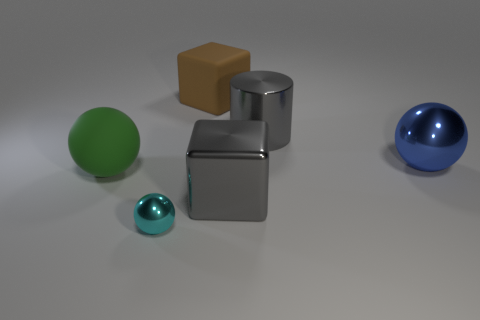Are there any other things that have the same size as the cyan shiny sphere?
Your response must be concise. No. What is the tiny cyan object made of?
Offer a terse response. Metal. What is the sphere that is on the left side of the metal object in front of the big gray shiny object that is to the left of the cylinder made of?
Offer a terse response. Rubber. There is a brown thing that is the same size as the matte sphere; what shape is it?
Your answer should be very brief. Cube. What number of objects are big brown rubber spheres or large objects behind the large blue sphere?
Give a very brief answer. 2. Is the material of the large sphere that is in front of the large shiny ball the same as the block that is behind the large blue ball?
Provide a short and direct response. Yes. There is a thing that is the same color as the metal cylinder; what shape is it?
Offer a terse response. Cube. What number of brown objects are tiny metallic objects or large metal cylinders?
Provide a succinct answer. 0. What size is the green matte thing?
Ensure brevity in your answer.  Large. Are there more objects behind the gray cube than cylinders?
Provide a short and direct response. Yes. 